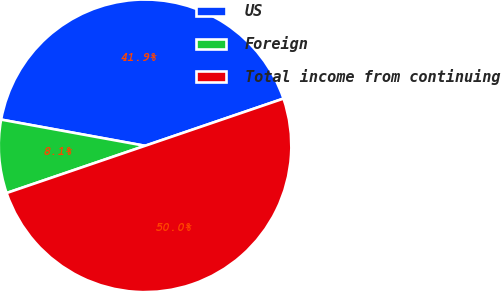<chart> <loc_0><loc_0><loc_500><loc_500><pie_chart><fcel>US<fcel>Foreign<fcel>Total income from continuing<nl><fcel>41.9%<fcel>8.1%<fcel>50.0%<nl></chart> 